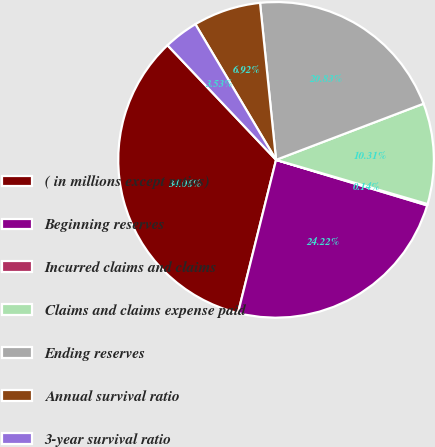<chart> <loc_0><loc_0><loc_500><loc_500><pie_chart><fcel>( in millions except ratios)<fcel>Beginning reserves<fcel>Incurred claims and claims<fcel>Claims and claims expense paid<fcel>Ending reserves<fcel>Annual survival ratio<fcel>3-year survival ratio<nl><fcel>34.06%<fcel>24.22%<fcel>0.14%<fcel>10.31%<fcel>20.83%<fcel>6.92%<fcel>3.53%<nl></chart> 